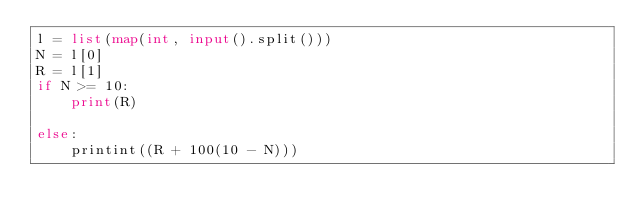<code> <loc_0><loc_0><loc_500><loc_500><_Python_>l = list(map(int, input().split()))
N = l[0]
R = l[1]
if N >= 10:
    print(R)

else:
    printint((R + 100(10 - N)))
    </code> 